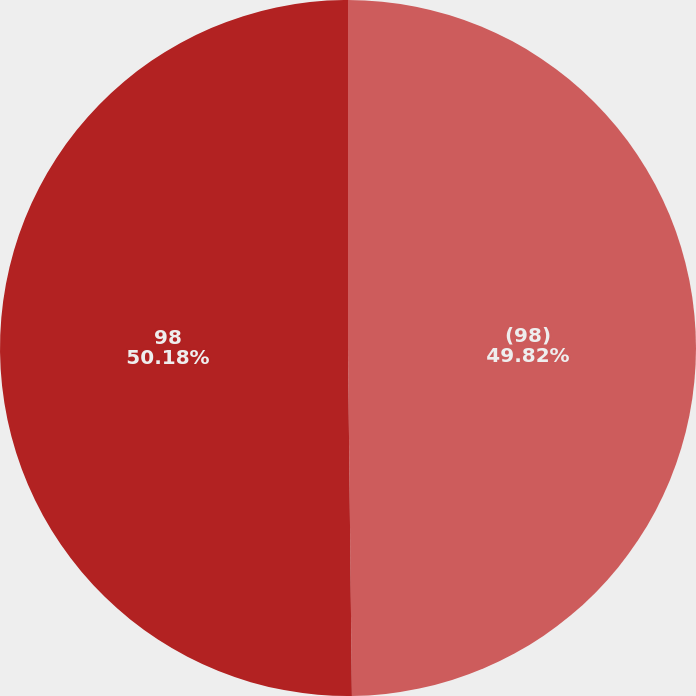<chart> <loc_0><loc_0><loc_500><loc_500><pie_chart><fcel>(98)<fcel>98<nl><fcel>49.82%<fcel>50.18%<nl></chart> 